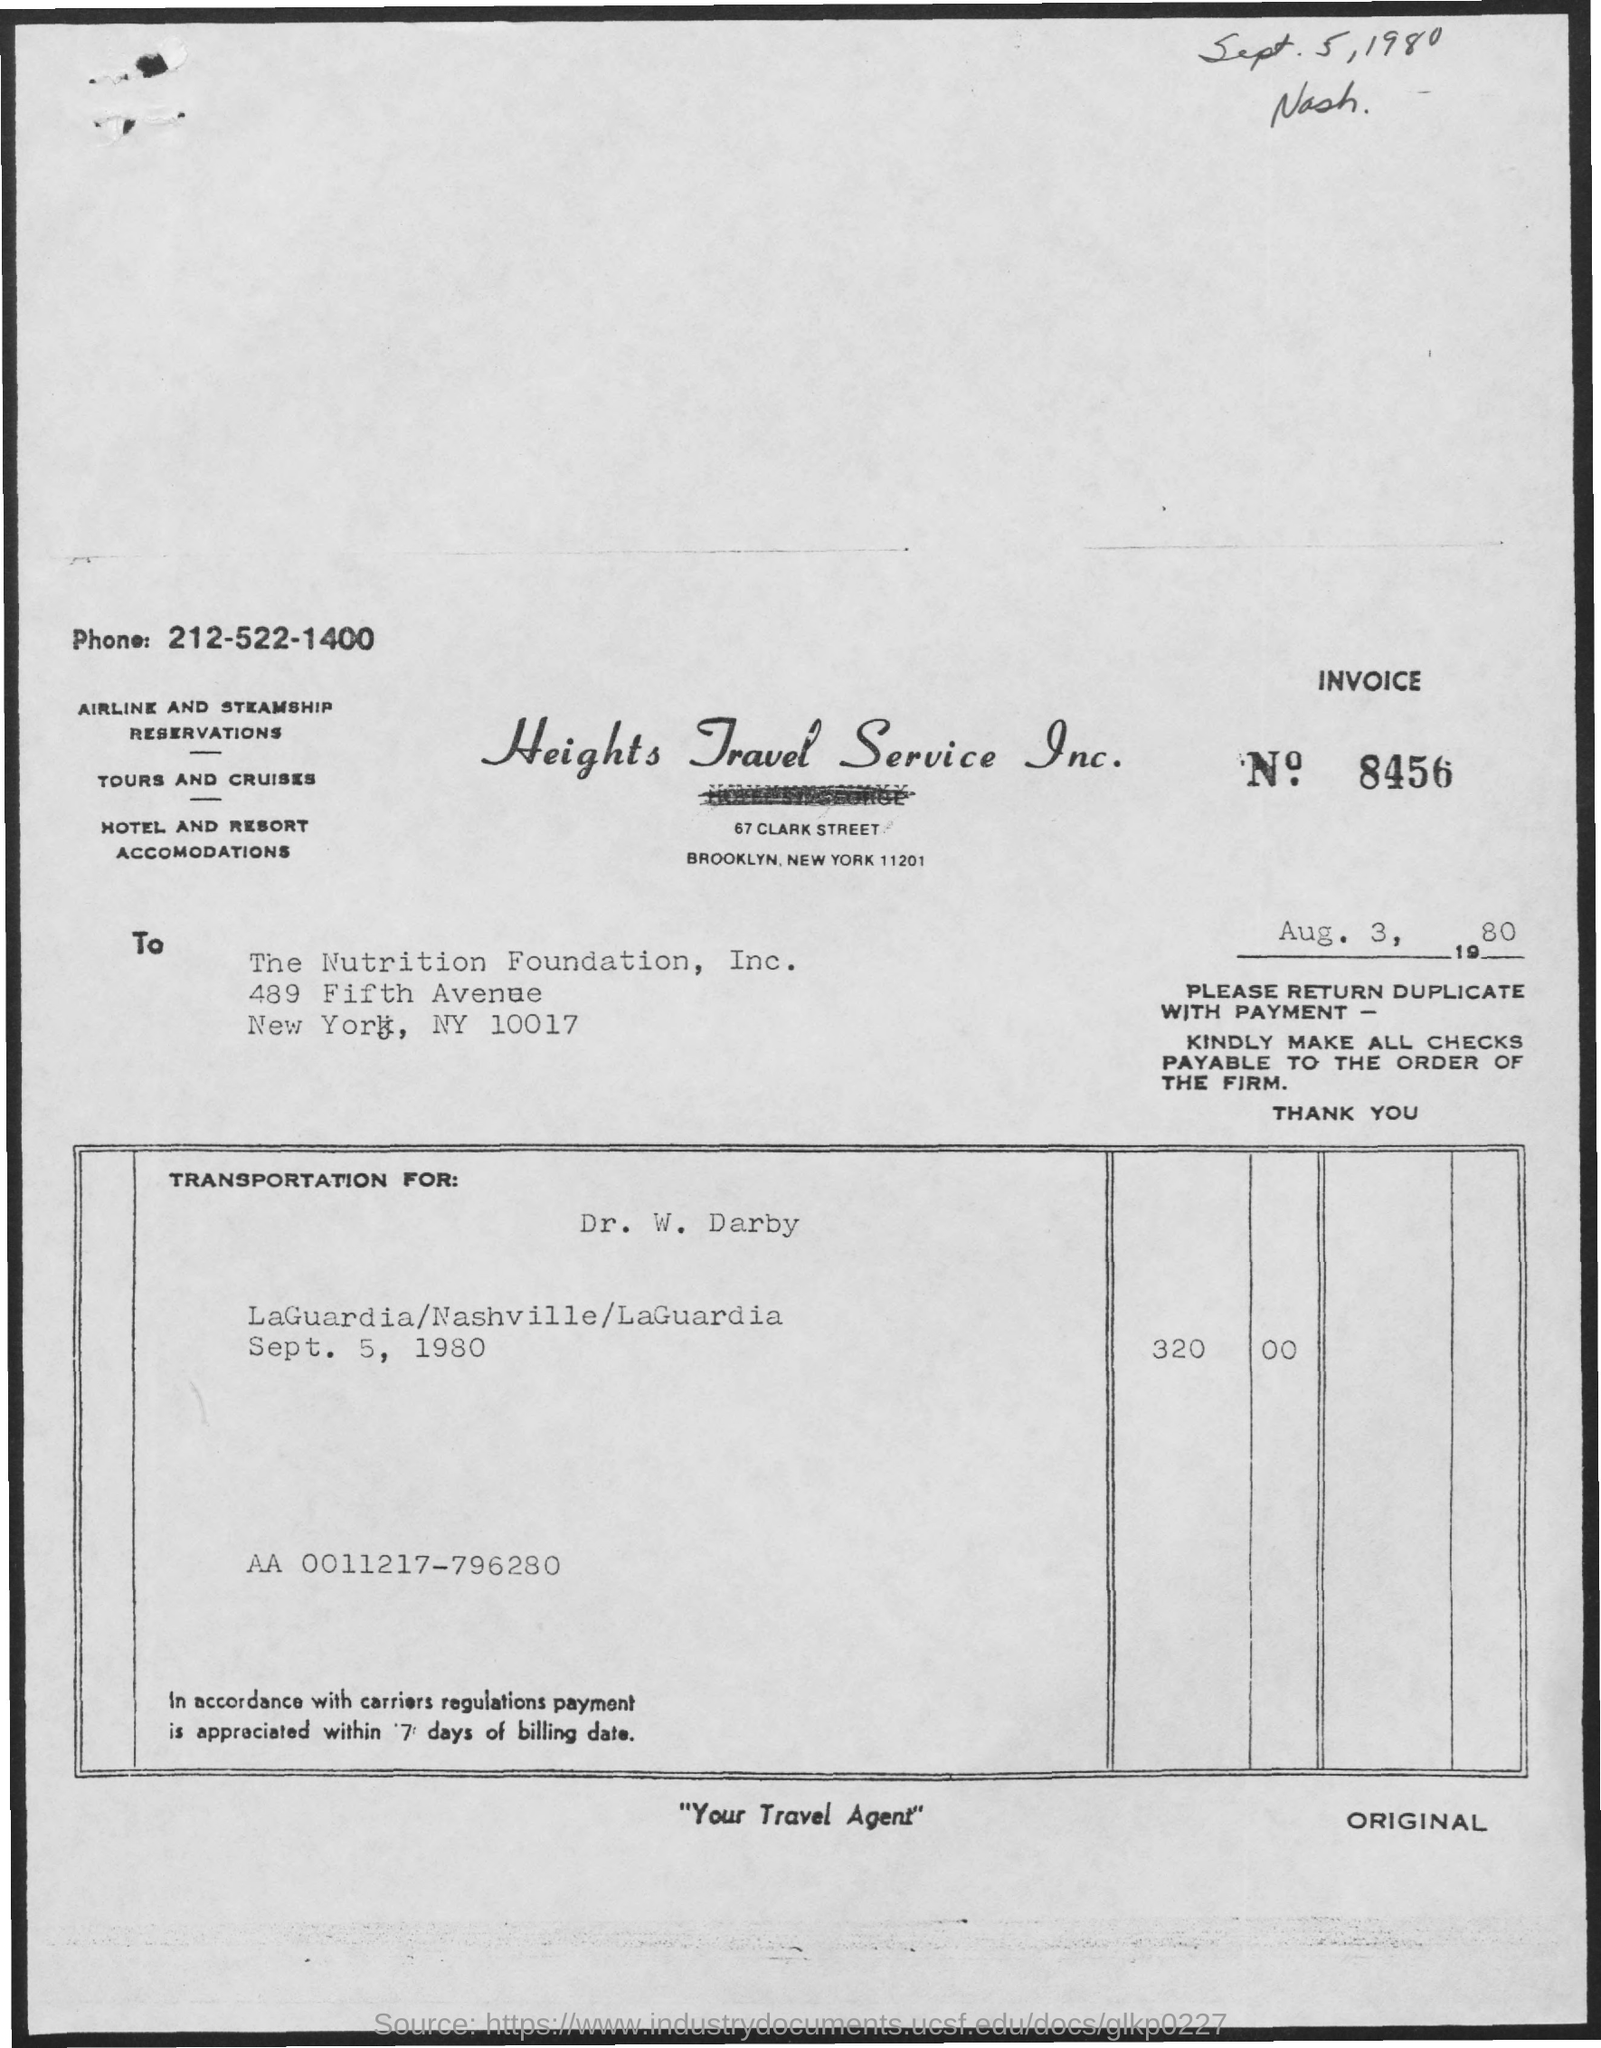What is the phone number given?
Provide a succinct answer. 212-522-1400. Which firm is mentioned at the top of the page?
Make the answer very short. Heights travel service inc. What is the Invoice No.?
Offer a very short reply. 8456. To whom is the invoice addressed?
Your response must be concise. The Nutrition Foundation, Inc. For whom is the transportation?
Give a very brief answer. Dr. W. Darby. What is the phrase written at the middle bottom of the page?
Your answer should be very brief. "your travel agent". What is the code written inside the box?
Your response must be concise. AA 0011217-796280. 